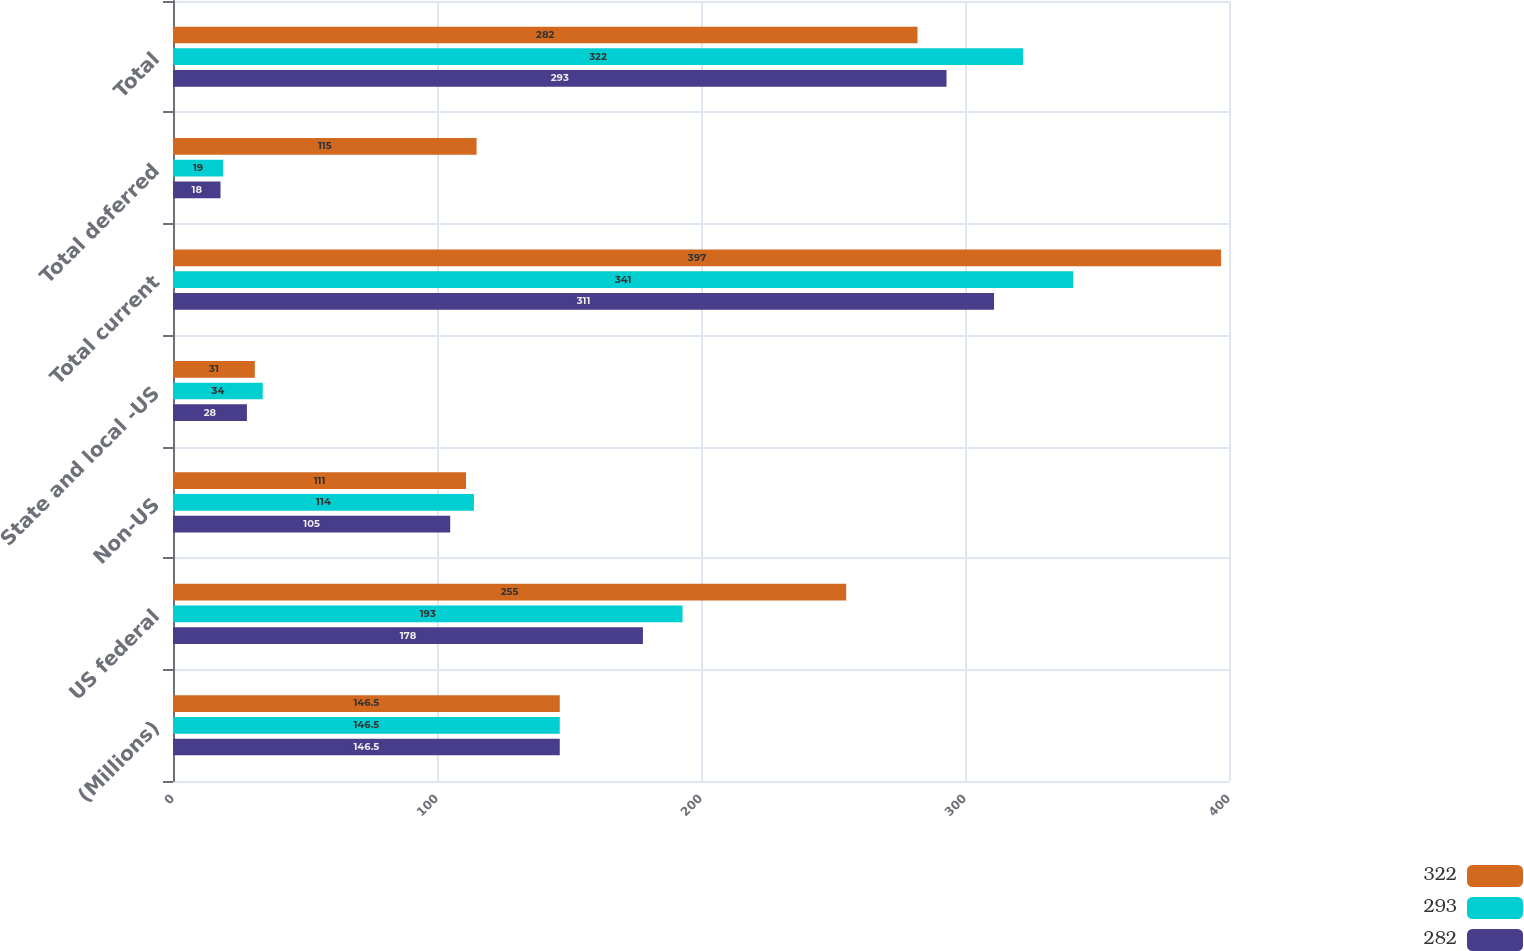Convert chart. <chart><loc_0><loc_0><loc_500><loc_500><stacked_bar_chart><ecel><fcel>(Millions)<fcel>US federal<fcel>Non-US<fcel>State and local -US<fcel>Total current<fcel>Total deferred<fcel>Total<nl><fcel>322<fcel>146.5<fcel>255<fcel>111<fcel>31<fcel>397<fcel>115<fcel>282<nl><fcel>293<fcel>146.5<fcel>193<fcel>114<fcel>34<fcel>341<fcel>19<fcel>322<nl><fcel>282<fcel>146.5<fcel>178<fcel>105<fcel>28<fcel>311<fcel>18<fcel>293<nl></chart> 